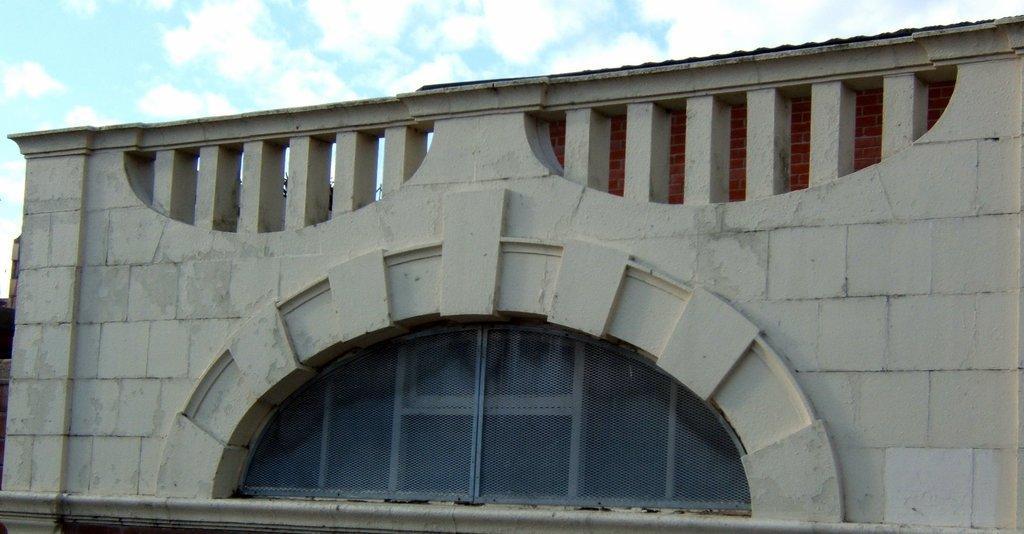Please provide a concise description of this image. This picture is clicked outside. In the foreground we can see the net which seems to be attached to the window of the building. In the background we can see the sky with the clouds. 